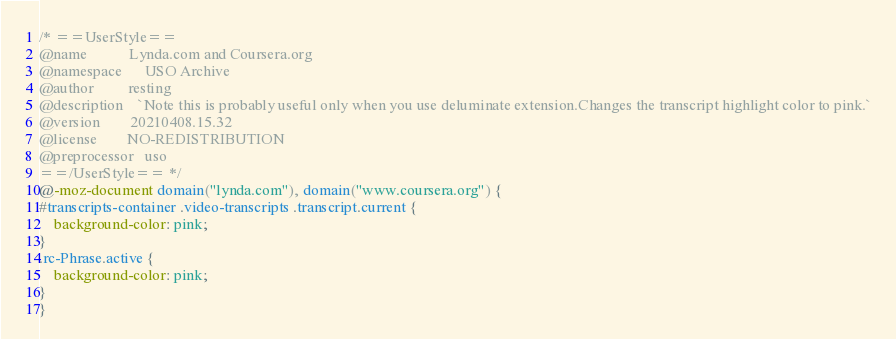<code> <loc_0><loc_0><loc_500><loc_500><_CSS_>/* ==UserStyle==
@name           Lynda.com and Coursera.org
@namespace      USO Archive
@author         resting
@description    `Note this is probably useful only when you use deluminate extension.Changes the transcript highlight color to pink.`
@version        20210408.15.32
@license        NO-REDISTRIBUTION
@preprocessor   uso
==/UserStyle== */
@-moz-document domain("lynda.com"), domain("www.coursera.org") {
#transcripts-container .video-transcripts .transcript.current {
	background-color: pink;
}
.rc-Phrase.active {
	background-color: pink;
}
}</code> 